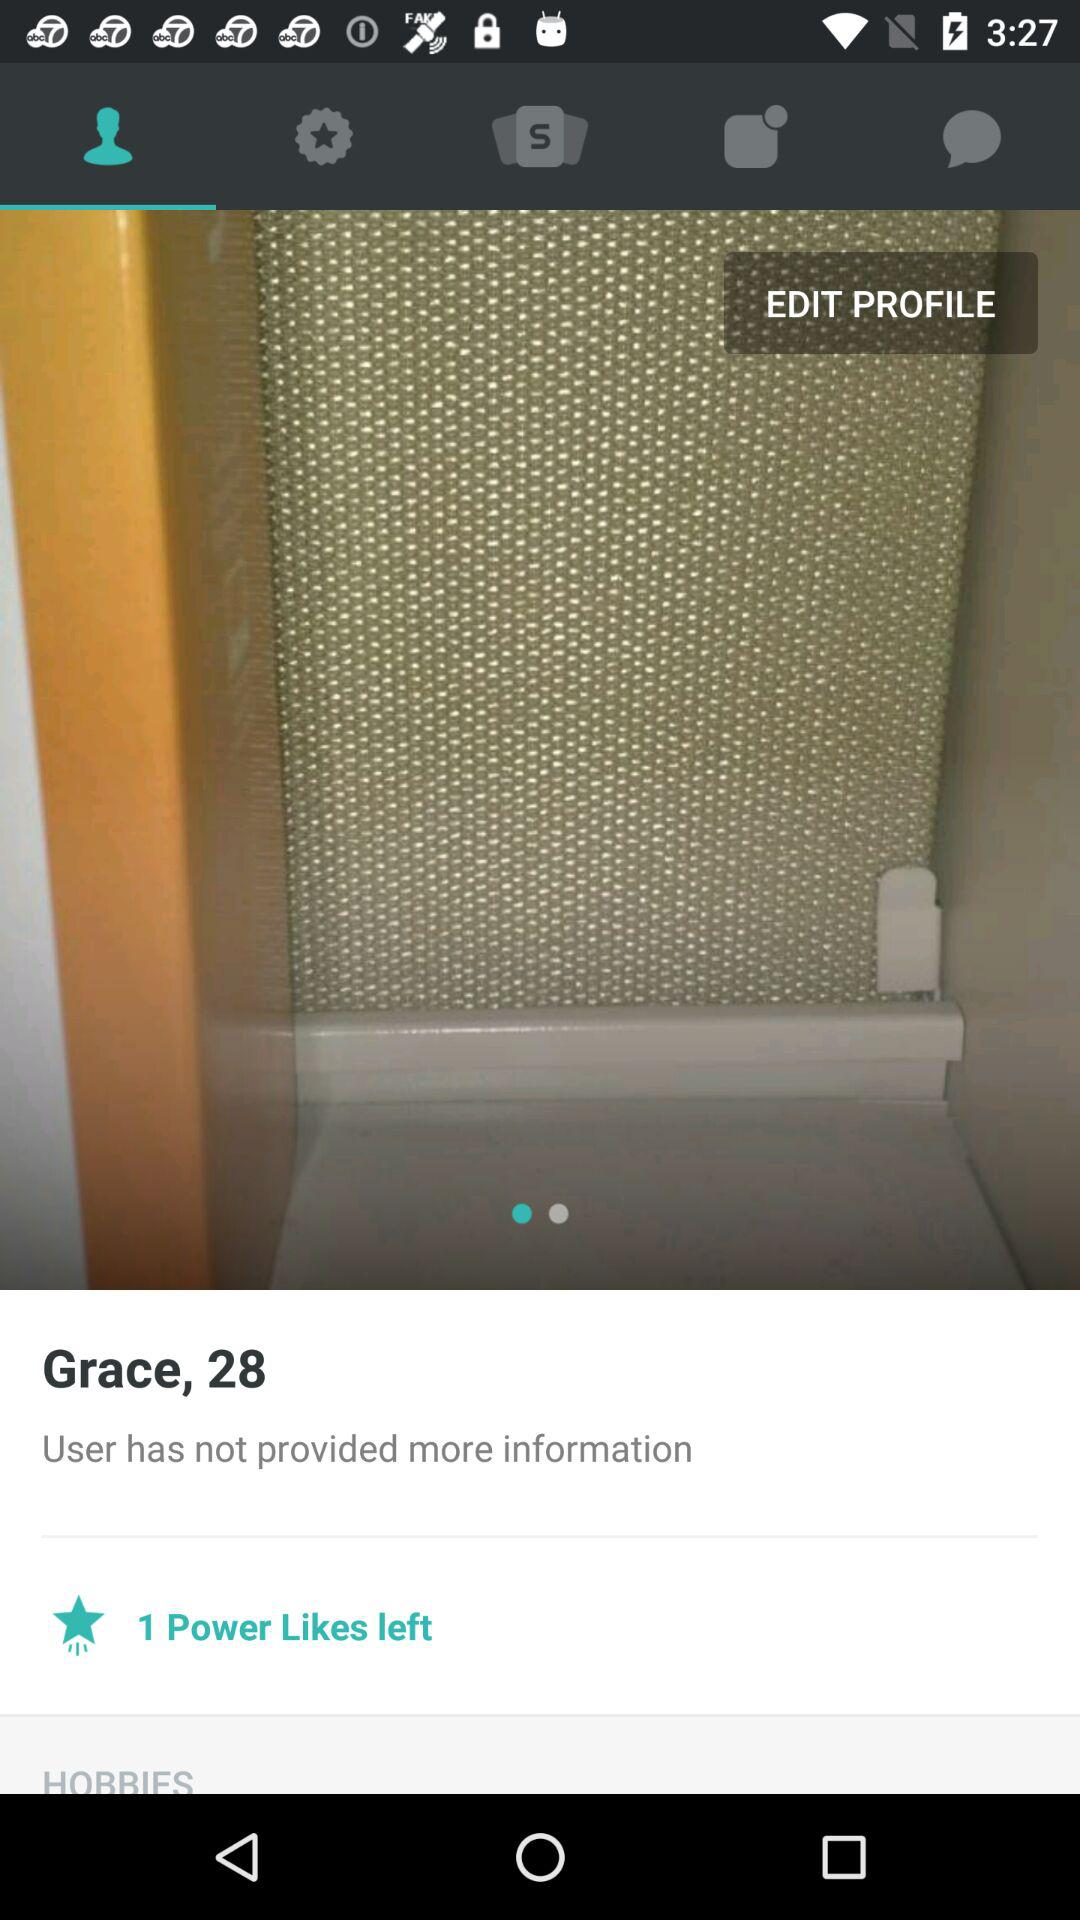What is the user name? The user name is Grace. 